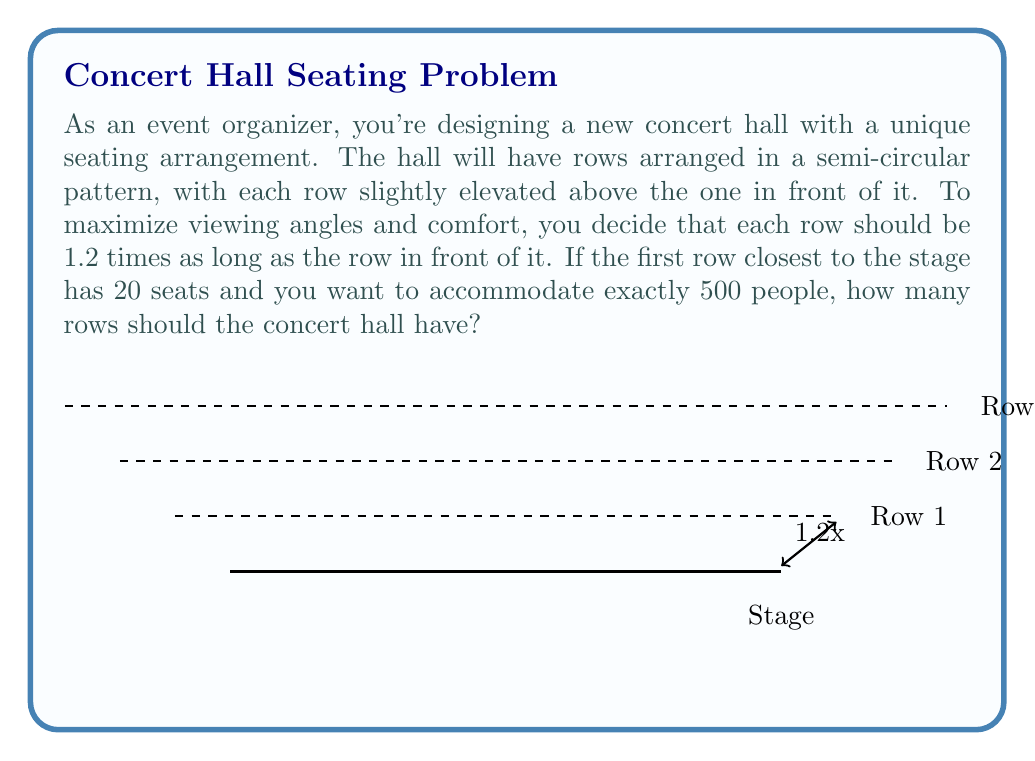Show me your answer to this math problem. Let's approach this step-by-step using geometric series:

1) Let $n$ be the number of rows we need to find.

2) The number of seats in each row forms a geometric sequence with:
   - First term $a = 20$ (seats in the first row)
   - Common ratio $r = 1.2$ (each row is 1.2 times longer than the previous)

3) The total number of seats $S_n$ is given by the sum of this geometric series:

   $$S_n = a\frac{1-r^n}{1-r}$$

4) We want this sum to equal 500:

   $$500 = 20\frac{1-1.2^n}{1-1.2}$$

5) Simplify:
   $$500 = 20\frac{1-1.2^n}{-0.2} = -100(1-1.2^n)$$

6) Solve for $1.2^n$:
   $$-5 = 1-1.2^n$$
   $$1.2^n = 6$$

7) Take logarithms of both sides:
   $$n\log(1.2) = \log(6)$$

8) Solve for $n$:
   $$n = \frac{\log(6)}{\log(1.2)} \approx 10.28$$

9) Since $n$ must be a whole number, and we can't have fewer than 500 seats, we round up to 11.

10) Verify: 
    $$S_{11} = 20\frac{1-1.2^{11}}{1-1.2} \approx 504.7$$

This confirms that 11 rows will accommodate slightly more than 500 people.
Answer: 11 rows 